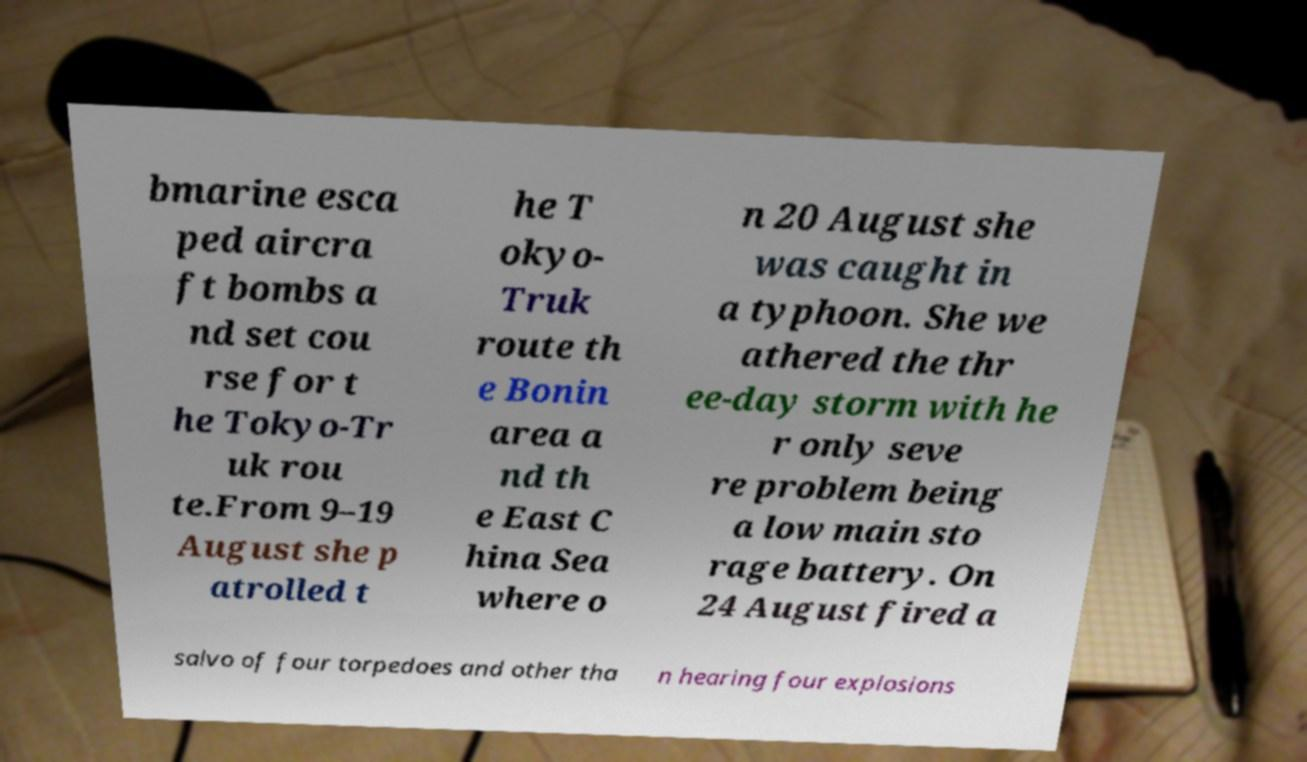Can you accurately transcribe the text from the provided image for me? bmarine esca ped aircra ft bombs a nd set cou rse for t he Tokyo-Tr uk rou te.From 9–19 August she p atrolled t he T okyo- Truk route th e Bonin area a nd th e East C hina Sea where o n 20 August she was caught in a typhoon. She we athered the thr ee-day storm with he r only seve re problem being a low main sto rage battery. On 24 August fired a salvo of four torpedoes and other tha n hearing four explosions 